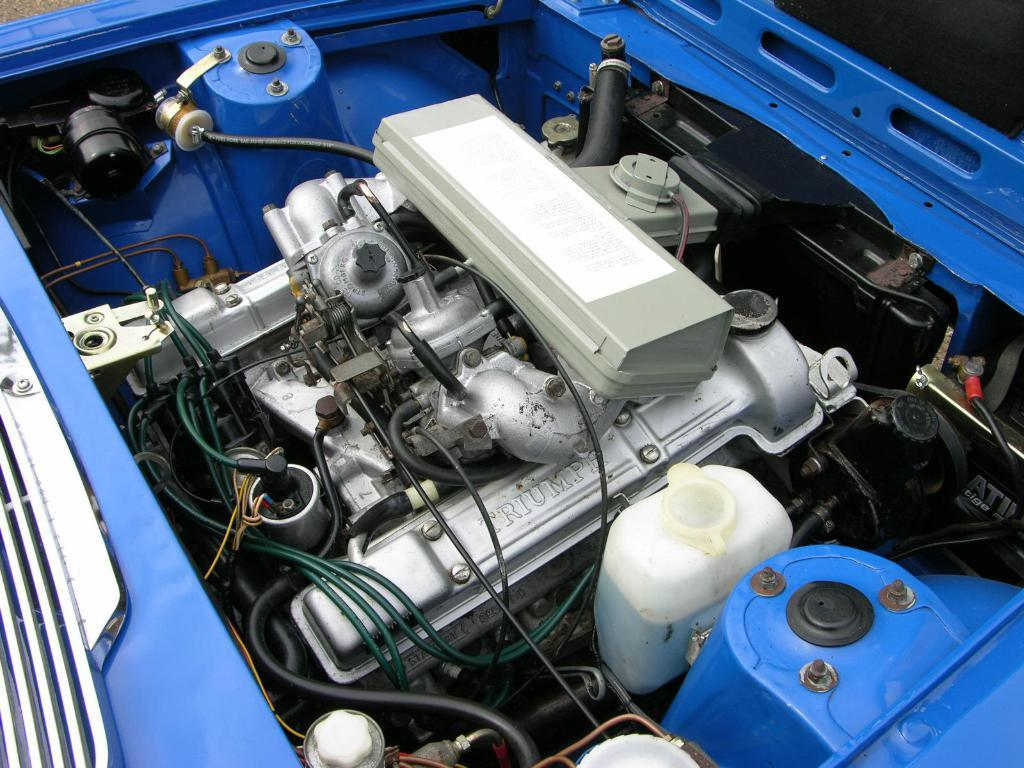What is the main subject of the image? There is a vehicle in the image. What is the state of the vehicle in the image? The hood of the vehicle is open. What type of leather is used to make the brake pads in the image? There is no mention of brake pads or leather in the image, as it only shows a vehicle with an open hood. 